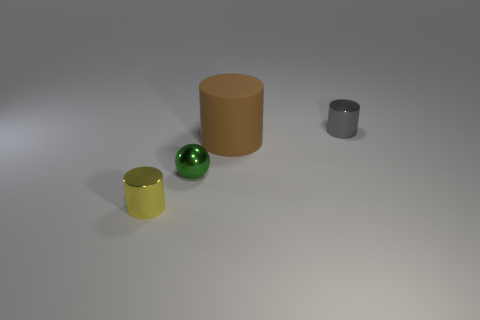Is there anything else that is the same material as the brown cylinder?
Provide a short and direct response. No. Are there an equal number of big brown things behind the brown matte object and yellow objects that are in front of the small green metal thing?
Your answer should be very brief. No. There is a thing that is both on the left side of the brown thing and right of the yellow object; what is it made of?
Provide a short and direct response. Metal. There is a gray thing; is it the same size as the cylinder that is left of the brown rubber thing?
Keep it short and to the point. Yes. How many other objects are there of the same color as the metallic ball?
Provide a succinct answer. 0. Is the number of green metallic spheres that are right of the big brown matte cylinder greater than the number of brown rubber objects?
Give a very brief answer. No. What color is the big matte object that is left of the tiny cylinder that is behind the tiny metal cylinder on the left side of the gray cylinder?
Your answer should be compact. Brown. Is the gray thing made of the same material as the tiny yellow cylinder?
Offer a very short reply. Yes. Are there any cyan rubber things of the same size as the gray metal object?
Ensure brevity in your answer.  No. There is another cylinder that is the same size as the yellow cylinder; what material is it?
Keep it short and to the point. Metal. 